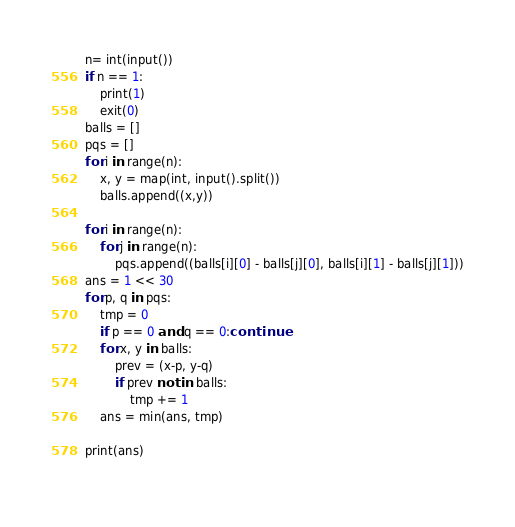Convert code to text. <code><loc_0><loc_0><loc_500><loc_500><_Python_>n= int(input())
if n == 1:
    print(1)
    exit(0)
balls = []
pqs = []
for i in range(n):
    x, y = map(int, input().split())
    balls.append((x,y))

for i in range(n):
    for j in range(n):
        pqs.append((balls[i][0] - balls[j][0], balls[i][1] - balls[j][1]))
ans = 1 << 30
for p, q in pqs:
    tmp = 0
    if p == 0 and q == 0:continue
    for x, y in balls:
        prev = (x-p, y-q)
        if prev not in balls:
            tmp += 1
    ans = min(ans, tmp)

print(ans)
    </code> 